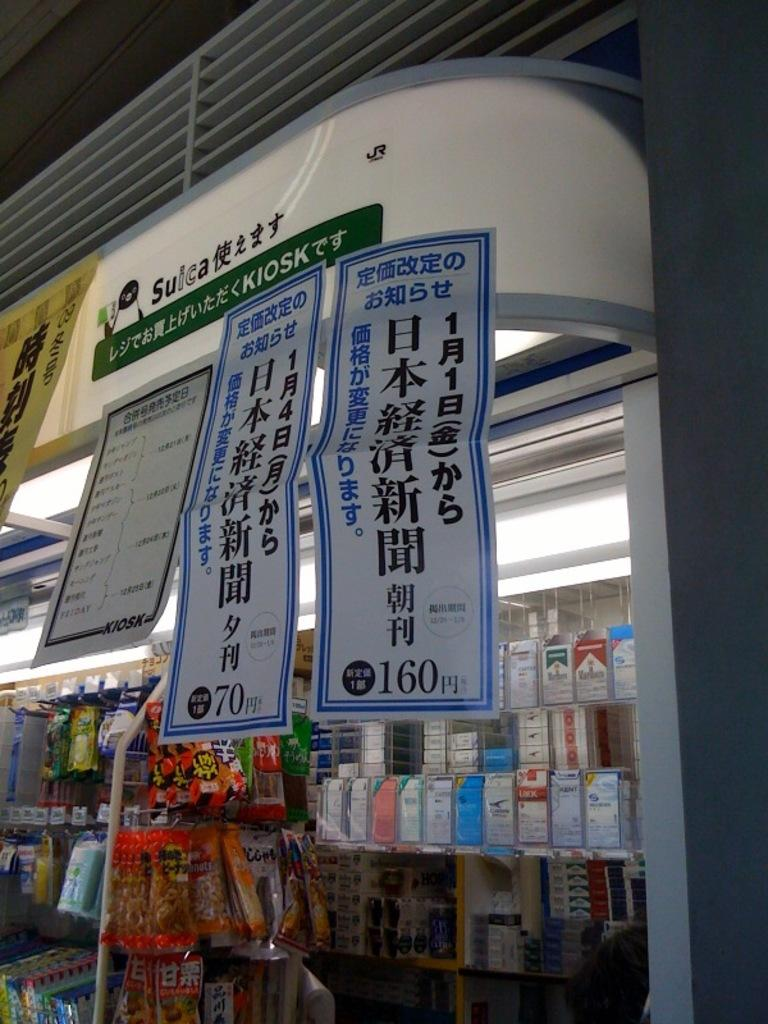Provide a one-sentence caption for the provided image. Retail store in China with Chinese posters on the window. 